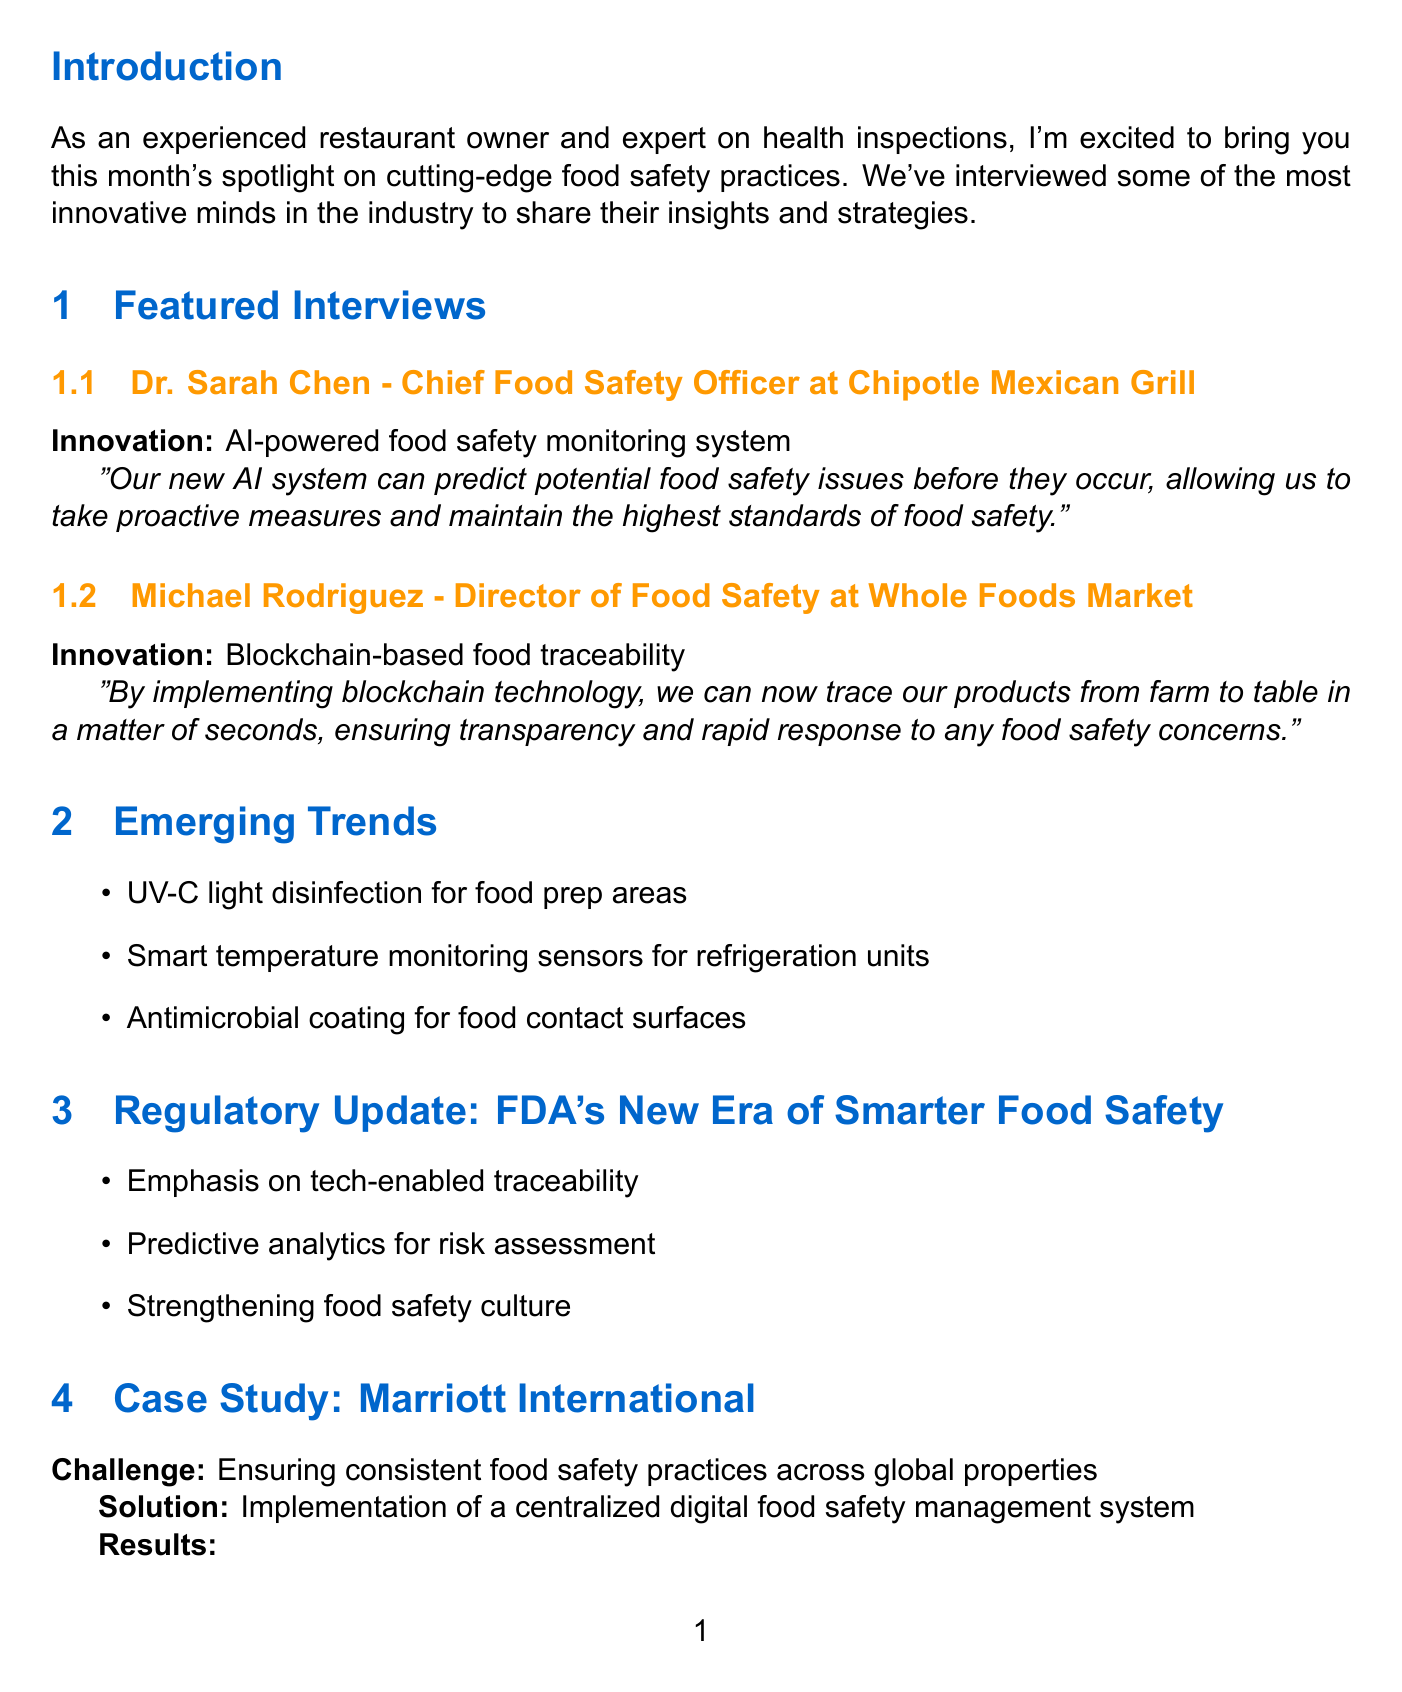What is the title of the newsletter? The title of the newsletter is stated at the beginning as "Innovative Food Safety Practices: Insights from Industry Leaders."
Answer: Innovative Food Safety Practices: Insights from Industry Leaders Who is the Chief Food Safety Officer at Chipotle Mexican Grill? This document lists Dr. Sarah Chen as the Chief Food Safety Officer at Chipotle Mexican Grill.
Answer: Dr. Sarah Chen What percentage reduction in food safety incidents did Marriott International achieve? The newsletter mentions a 30% reduction in food safety incidents as a result of their implemented solution.
Answer: 30% What is one of the emerging trends mentioned in the newsletter? The newsletter lists several trends including "UV-C light disinfection for food prep areas" as one of the emerging trends.
Answer: UV-C light disinfection for food prep areas What is the key focus of the FDA's New Era of Smarter Food Safety? The regulatory update emphasizes "tech-enabled traceability" as a key focus.
Answer: Tech-enabled traceability What is the suggested expert tip related to food safety? Chef Thomas Keller advises to "Incorporate food safety discussions into daily pre-shift meetings."
Answer: Incorporate food safety discussions into daily pre-shift meetings What date is the Global Food Safety Initiative Conference scheduled for? The upcoming events section indicates the conference is scheduled for April 23-25, 2024.
Answer: April 23-25, 2024 What challenge did Marriott International face regarding food safety? The document states that Marriott International's challenge was ensuring consistent food safety practices across global properties.
Answer: Ensuring consistent food safety practices across global properties 